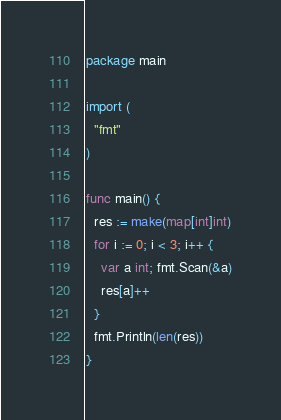Convert code to text. <code><loc_0><loc_0><loc_500><loc_500><_Go_>package main

import (
  "fmt"
)

func main() {
  res := make(map[int]int)
  for i := 0; i < 3; i++ {
    var a int; fmt.Scan(&a)
    res[a]++
  }
  fmt.Println(len(res))
}</code> 